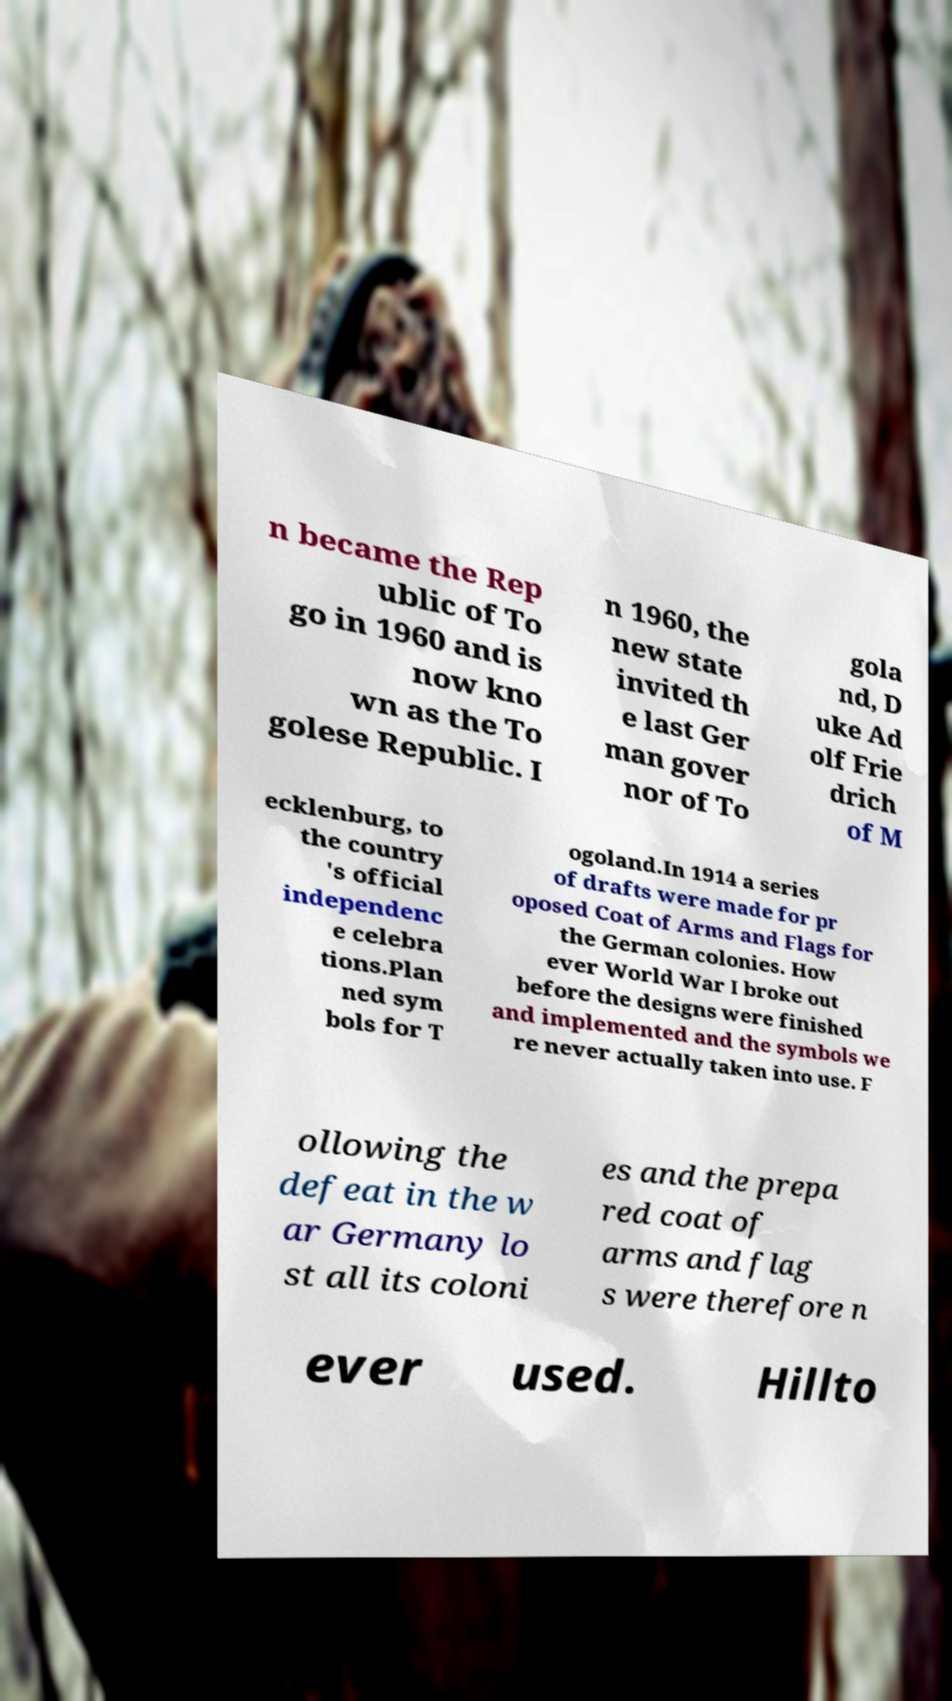Please identify and transcribe the text found in this image. n became the Rep ublic of To go in 1960 and is now kno wn as the To golese Republic. I n 1960, the new state invited th e last Ger man gover nor of To gola nd, D uke Ad olf Frie drich of M ecklenburg, to the country 's official independenc e celebra tions.Plan ned sym bols for T ogoland.In 1914 a series of drafts were made for pr oposed Coat of Arms and Flags for the German colonies. How ever World War I broke out before the designs were finished and implemented and the symbols we re never actually taken into use. F ollowing the defeat in the w ar Germany lo st all its coloni es and the prepa red coat of arms and flag s were therefore n ever used. Hillto 